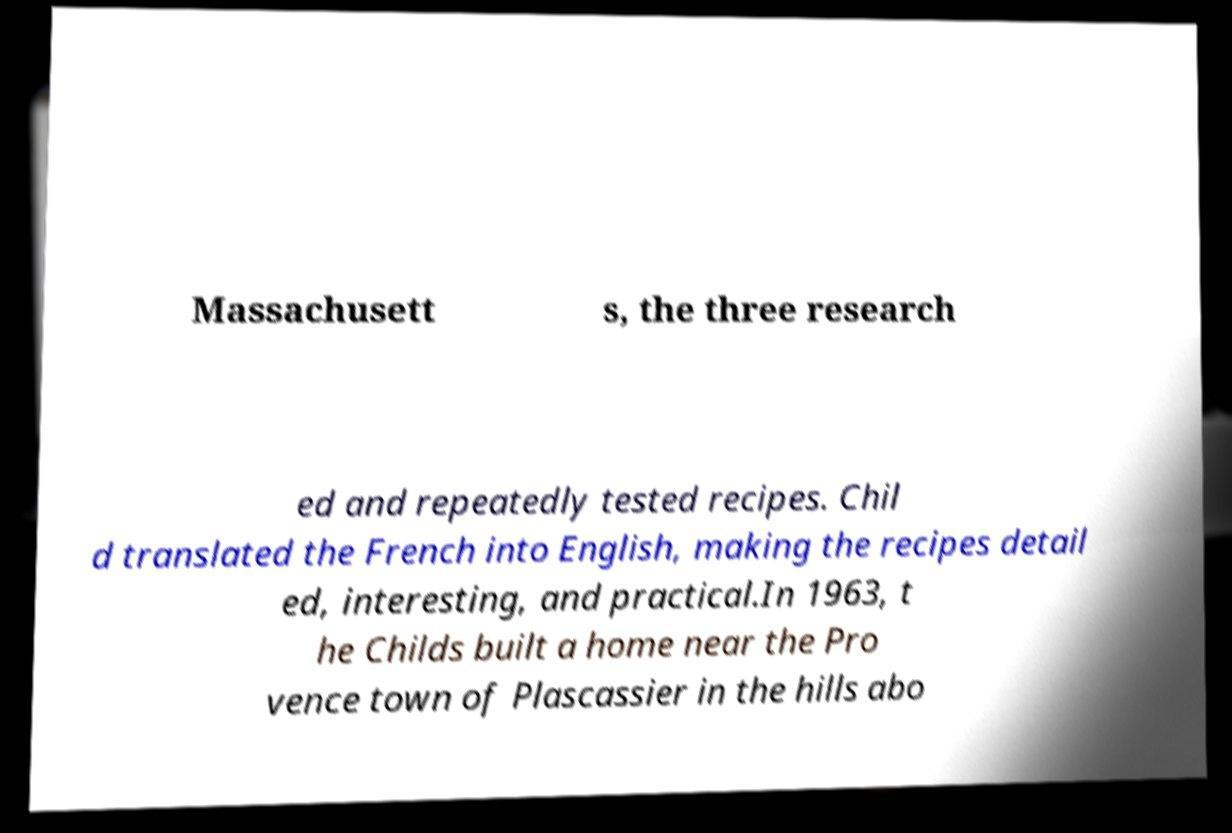Can you read and provide the text displayed in the image?This photo seems to have some interesting text. Can you extract and type it out for me? Massachusett s, the three research ed and repeatedly tested recipes. Chil d translated the French into English, making the recipes detail ed, interesting, and practical.In 1963, t he Childs built a home near the Pro vence town of Plascassier in the hills abo 